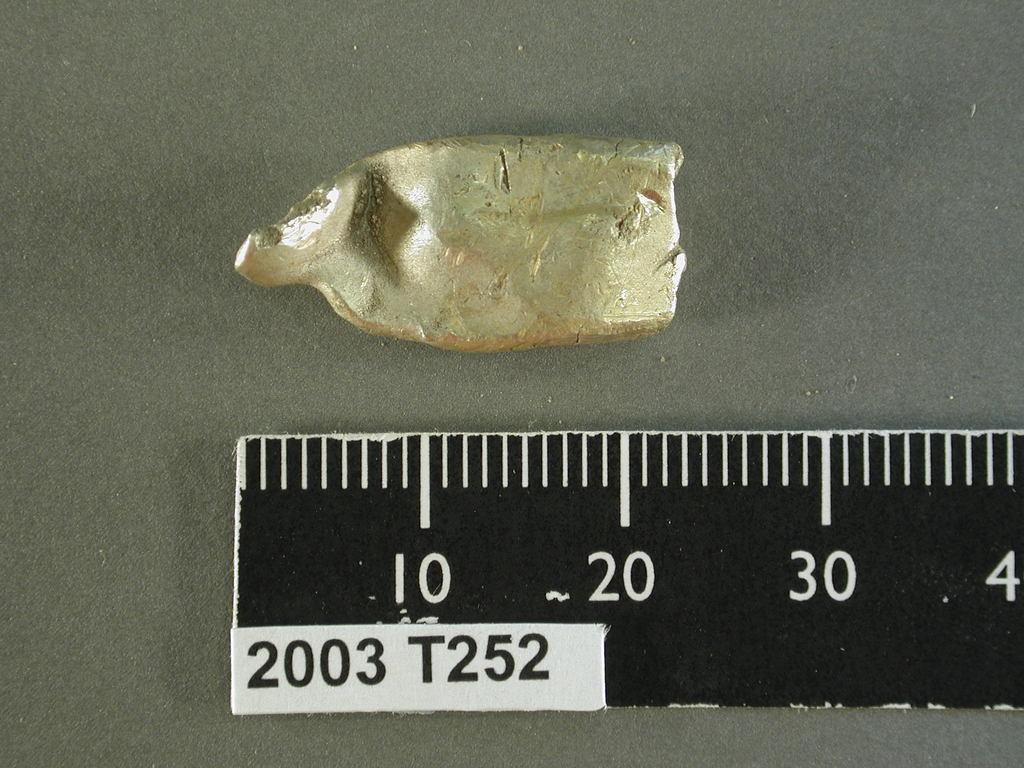<image>
Present a compact description of the photo's key features. The ruler with a 2003 T252 sticker shows the gold object is 22 mm long. 